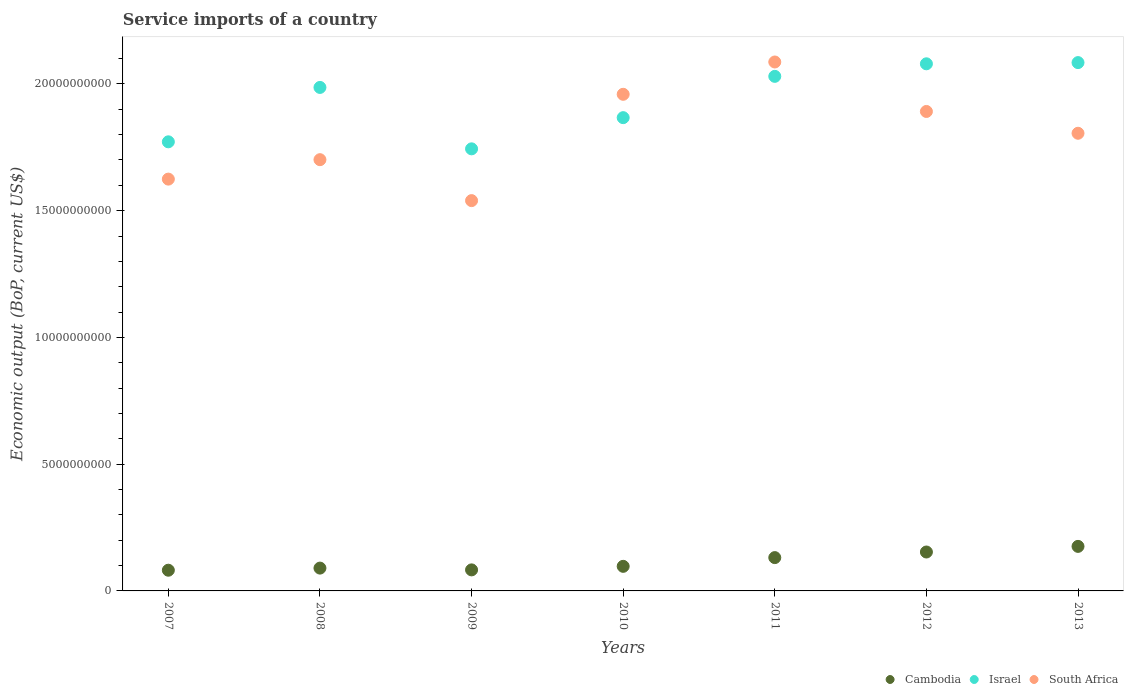How many different coloured dotlines are there?
Offer a terse response. 3. What is the service imports in South Africa in 2008?
Make the answer very short. 1.70e+1. Across all years, what is the maximum service imports in Israel?
Offer a very short reply. 2.08e+1. Across all years, what is the minimum service imports in Cambodia?
Provide a succinct answer. 8.17e+08. What is the total service imports in South Africa in the graph?
Make the answer very short. 1.26e+11. What is the difference between the service imports in South Africa in 2007 and that in 2009?
Offer a very short reply. 8.48e+08. What is the difference between the service imports in Cambodia in 2011 and the service imports in Israel in 2008?
Your response must be concise. -1.85e+1. What is the average service imports in South Africa per year?
Offer a very short reply. 1.80e+1. In the year 2009, what is the difference between the service imports in Cambodia and service imports in South Africa?
Ensure brevity in your answer.  -1.46e+1. What is the ratio of the service imports in South Africa in 2008 to that in 2011?
Provide a succinct answer. 0.82. What is the difference between the highest and the second highest service imports in Cambodia?
Provide a short and direct response. 2.22e+08. What is the difference between the highest and the lowest service imports in Cambodia?
Provide a succinct answer. 9.40e+08. In how many years, is the service imports in Israel greater than the average service imports in Israel taken over all years?
Give a very brief answer. 4. Is the sum of the service imports in Cambodia in 2008 and 2009 greater than the maximum service imports in Israel across all years?
Give a very brief answer. No. Is it the case that in every year, the sum of the service imports in Israel and service imports in Cambodia  is greater than the service imports in South Africa?
Your answer should be very brief. Yes. Does the service imports in South Africa monotonically increase over the years?
Provide a succinct answer. No. Is the service imports in Israel strictly greater than the service imports in South Africa over the years?
Your response must be concise. No. Is the service imports in South Africa strictly less than the service imports in Israel over the years?
Provide a succinct answer. No. How many dotlines are there?
Ensure brevity in your answer.  3. How many years are there in the graph?
Provide a short and direct response. 7. What is the difference between two consecutive major ticks on the Y-axis?
Give a very brief answer. 5.00e+09. Does the graph contain any zero values?
Make the answer very short. No. How many legend labels are there?
Offer a terse response. 3. What is the title of the graph?
Ensure brevity in your answer.  Service imports of a country. What is the label or title of the X-axis?
Provide a short and direct response. Years. What is the label or title of the Y-axis?
Ensure brevity in your answer.  Economic output (BoP, current US$). What is the Economic output (BoP, current US$) of Cambodia in 2007?
Keep it short and to the point. 8.17e+08. What is the Economic output (BoP, current US$) in Israel in 2007?
Provide a short and direct response. 1.77e+1. What is the Economic output (BoP, current US$) of South Africa in 2007?
Provide a short and direct response. 1.62e+1. What is the Economic output (BoP, current US$) in Cambodia in 2008?
Your response must be concise. 9.00e+08. What is the Economic output (BoP, current US$) of Israel in 2008?
Keep it short and to the point. 1.99e+1. What is the Economic output (BoP, current US$) of South Africa in 2008?
Ensure brevity in your answer.  1.70e+1. What is the Economic output (BoP, current US$) of Cambodia in 2009?
Give a very brief answer. 8.30e+08. What is the Economic output (BoP, current US$) of Israel in 2009?
Make the answer very short. 1.74e+1. What is the Economic output (BoP, current US$) in South Africa in 2009?
Offer a terse response. 1.54e+1. What is the Economic output (BoP, current US$) of Cambodia in 2010?
Provide a short and direct response. 9.70e+08. What is the Economic output (BoP, current US$) in Israel in 2010?
Your answer should be compact. 1.87e+1. What is the Economic output (BoP, current US$) in South Africa in 2010?
Your response must be concise. 1.96e+1. What is the Economic output (BoP, current US$) of Cambodia in 2011?
Offer a terse response. 1.31e+09. What is the Economic output (BoP, current US$) in Israel in 2011?
Your response must be concise. 2.03e+1. What is the Economic output (BoP, current US$) in South Africa in 2011?
Your response must be concise. 2.09e+1. What is the Economic output (BoP, current US$) in Cambodia in 2012?
Provide a short and direct response. 1.54e+09. What is the Economic output (BoP, current US$) in Israel in 2012?
Make the answer very short. 2.08e+1. What is the Economic output (BoP, current US$) of South Africa in 2012?
Make the answer very short. 1.89e+1. What is the Economic output (BoP, current US$) of Cambodia in 2013?
Offer a very short reply. 1.76e+09. What is the Economic output (BoP, current US$) of Israel in 2013?
Provide a succinct answer. 2.08e+1. What is the Economic output (BoP, current US$) of South Africa in 2013?
Give a very brief answer. 1.81e+1. Across all years, what is the maximum Economic output (BoP, current US$) in Cambodia?
Ensure brevity in your answer.  1.76e+09. Across all years, what is the maximum Economic output (BoP, current US$) in Israel?
Offer a very short reply. 2.08e+1. Across all years, what is the maximum Economic output (BoP, current US$) in South Africa?
Offer a terse response. 2.09e+1. Across all years, what is the minimum Economic output (BoP, current US$) in Cambodia?
Provide a succinct answer. 8.17e+08. Across all years, what is the minimum Economic output (BoP, current US$) of Israel?
Make the answer very short. 1.74e+1. Across all years, what is the minimum Economic output (BoP, current US$) of South Africa?
Provide a succinct answer. 1.54e+1. What is the total Economic output (BoP, current US$) in Cambodia in the graph?
Ensure brevity in your answer.  8.12e+09. What is the total Economic output (BoP, current US$) of Israel in the graph?
Your answer should be compact. 1.36e+11. What is the total Economic output (BoP, current US$) in South Africa in the graph?
Ensure brevity in your answer.  1.26e+11. What is the difference between the Economic output (BoP, current US$) in Cambodia in 2007 and that in 2008?
Your response must be concise. -8.33e+07. What is the difference between the Economic output (BoP, current US$) in Israel in 2007 and that in 2008?
Give a very brief answer. -2.15e+09. What is the difference between the Economic output (BoP, current US$) in South Africa in 2007 and that in 2008?
Make the answer very short. -7.67e+08. What is the difference between the Economic output (BoP, current US$) of Cambodia in 2007 and that in 2009?
Your answer should be very brief. -1.34e+07. What is the difference between the Economic output (BoP, current US$) in Israel in 2007 and that in 2009?
Make the answer very short. 2.77e+08. What is the difference between the Economic output (BoP, current US$) in South Africa in 2007 and that in 2009?
Ensure brevity in your answer.  8.48e+08. What is the difference between the Economic output (BoP, current US$) of Cambodia in 2007 and that in 2010?
Offer a very short reply. -1.53e+08. What is the difference between the Economic output (BoP, current US$) in Israel in 2007 and that in 2010?
Provide a short and direct response. -9.53e+08. What is the difference between the Economic output (BoP, current US$) in South Africa in 2007 and that in 2010?
Give a very brief answer. -3.35e+09. What is the difference between the Economic output (BoP, current US$) in Cambodia in 2007 and that in 2011?
Provide a short and direct response. -4.97e+08. What is the difference between the Economic output (BoP, current US$) in Israel in 2007 and that in 2011?
Offer a very short reply. -2.58e+09. What is the difference between the Economic output (BoP, current US$) of South Africa in 2007 and that in 2011?
Your answer should be compact. -4.62e+09. What is the difference between the Economic output (BoP, current US$) in Cambodia in 2007 and that in 2012?
Keep it short and to the point. -7.18e+08. What is the difference between the Economic output (BoP, current US$) in Israel in 2007 and that in 2012?
Offer a very short reply. -3.08e+09. What is the difference between the Economic output (BoP, current US$) in South Africa in 2007 and that in 2012?
Provide a succinct answer. -2.67e+09. What is the difference between the Economic output (BoP, current US$) in Cambodia in 2007 and that in 2013?
Make the answer very short. -9.40e+08. What is the difference between the Economic output (BoP, current US$) in Israel in 2007 and that in 2013?
Make the answer very short. -3.13e+09. What is the difference between the Economic output (BoP, current US$) of South Africa in 2007 and that in 2013?
Your answer should be compact. -1.81e+09. What is the difference between the Economic output (BoP, current US$) of Cambodia in 2008 and that in 2009?
Provide a succinct answer. 6.99e+07. What is the difference between the Economic output (BoP, current US$) of Israel in 2008 and that in 2009?
Provide a short and direct response. 2.42e+09. What is the difference between the Economic output (BoP, current US$) in South Africa in 2008 and that in 2009?
Your answer should be compact. 1.62e+09. What is the difference between the Economic output (BoP, current US$) of Cambodia in 2008 and that in 2010?
Your answer should be compact. -6.98e+07. What is the difference between the Economic output (BoP, current US$) of Israel in 2008 and that in 2010?
Offer a terse response. 1.19e+09. What is the difference between the Economic output (BoP, current US$) of South Africa in 2008 and that in 2010?
Keep it short and to the point. -2.58e+09. What is the difference between the Economic output (BoP, current US$) in Cambodia in 2008 and that in 2011?
Make the answer very short. -4.14e+08. What is the difference between the Economic output (BoP, current US$) of Israel in 2008 and that in 2011?
Your answer should be very brief. -4.37e+08. What is the difference between the Economic output (BoP, current US$) in South Africa in 2008 and that in 2011?
Keep it short and to the point. -3.85e+09. What is the difference between the Economic output (BoP, current US$) of Cambodia in 2008 and that in 2012?
Give a very brief answer. -6.35e+08. What is the difference between the Economic output (BoP, current US$) of Israel in 2008 and that in 2012?
Your response must be concise. -9.32e+08. What is the difference between the Economic output (BoP, current US$) in South Africa in 2008 and that in 2012?
Your answer should be very brief. -1.90e+09. What is the difference between the Economic output (BoP, current US$) of Cambodia in 2008 and that in 2013?
Offer a terse response. -8.57e+08. What is the difference between the Economic output (BoP, current US$) in Israel in 2008 and that in 2013?
Provide a short and direct response. -9.80e+08. What is the difference between the Economic output (BoP, current US$) of South Africa in 2008 and that in 2013?
Offer a terse response. -1.04e+09. What is the difference between the Economic output (BoP, current US$) of Cambodia in 2009 and that in 2010?
Your response must be concise. -1.40e+08. What is the difference between the Economic output (BoP, current US$) in Israel in 2009 and that in 2010?
Your answer should be compact. -1.23e+09. What is the difference between the Economic output (BoP, current US$) in South Africa in 2009 and that in 2010?
Your answer should be compact. -4.19e+09. What is the difference between the Economic output (BoP, current US$) of Cambodia in 2009 and that in 2011?
Ensure brevity in your answer.  -4.84e+08. What is the difference between the Economic output (BoP, current US$) of Israel in 2009 and that in 2011?
Make the answer very short. -2.86e+09. What is the difference between the Economic output (BoP, current US$) of South Africa in 2009 and that in 2011?
Make the answer very short. -5.47e+09. What is the difference between the Economic output (BoP, current US$) in Cambodia in 2009 and that in 2012?
Provide a succinct answer. -7.05e+08. What is the difference between the Economic output (BoP, current US$) of Israel in 2009 and that in 2012?
Offer a very short reply. -3.35e+09. What is the difference between the Economic output (BoP, current US$) in South Africa in 2009 and that in 2012?
Offer a terse response. -3.52e+09. What is the difference between the Economic output (BoP, current US$) of Cambodia in 2009 and that in 2013?
Keep it short and to the point. -9.27e+08. What is the difference between the Economic output (BoP, current US$) in Israel in 2009 and that in 2013?
Your answer should be compact. -3.40e+09. What is the difference between the Economic output (BoP, current US$) in South Africa in 2009 and that in 2013?
Ensure brevity in your answer.  -2.66e+09. What is the difference between the Economic output (BoP, current US$) in Cambodia in 2010 and that in 2011?
Provide a succinct answer. -3.44e+08. What is the difference between the Economic output (BoP, current US$) in Israel in 2010 and that in 2011?
Make the answer very short. -1.63e+09. What is the difference between the Economic output (BoP, current US$) of South Africa in 2010 and that in 2011?
Offer a very short reply. -1.27e+09. What is the difference between the Economic output (BoP, current US$) in Cambodia in 2010 and that in 2012?
Make the answer very short. -5.65e+08. What is the difference between the Economic output (BoP, current US$) in Israel in 2010 and that in 2012?
Keep it short and to the point. -2.12e+09. What is the difference between the Economic output (BoP, current US$) in South Africa in 2010 and that in 2012?
Provide a succinct answer. 6.77e+08. What is the difference between the Economic output (BoP, current US$) in Cambodia in 2010 and that in 2013?
Your response must be concise. -7.87e+08. What is the difference between the Economic output (BoP, current US$) in Israel in 2010 and that in 2013?
Provide a short and direct response. -2.17e+09. What is the difference between the Economic output (BoP, current US$) in South Africa in 2010 and that in 2013?
Ensure brevity in your answer.  1.54e+09. What is the difference between the Economic output (BoP, current US$) of Cambodia in 2011 and that in 2012?
Offer a very short reply. -2.21e+08. What is the difference between the Economic output (BoP, current US$) in Israel in 2011 and that in 2012?
Give a very brief answer. -4.95e+08. What is the difference between the Economic output (BoP, current US$) of South Africa in 2011 and that in 2012?
Give a very brief answer. 1.95e+09. What is the difference between the Economic output (BoP, current US$) in Cambodia in 2011 and that in 2013?
Give a very brief answer. -4.43e+08. What is the difference between the Economic output (BoP, current US$) of Israel in 2011 and that in 2013?
Provide a succinct answer. -5.43e+08. What is the difference between the Economic output (BoP, current US$) of South Africa in 2011 and that in 2013?
Your response must be concise. 2.81e+09. What is the difference between the Economic output (BoP, current US$) of Cambodia in 2012 and that in 2013?
Your response must be concise. -2.22e+08. What is the difference between the Economic output (BoP, current US$) of Israel in 2012 and that in 2013?
Offer a very short reply. -4.77e+07. What is the difference between the Economic output (BoP, current US$) in South Africa in 2012 and that in 2013?
Provide a short and direct response. 8.60e+08. What is the difference between the Economic output (BoP, current US$) of Cambodia in 2007 and the Economic output (BoP, current US$) of Israel in 2008?
Offer a terse response. -1.90e+1. What is the difference between the Economic output (BoP, current US$) in Cambodia in 2007 and the Economic output (BoP, current US$) in South Africa in 2008?
Keep it short and to the point. -1.62e+1. What is the difference between the Economic output (BoP, current US$) in Israel in 2007 and the Economic output (BoP, current US$) in South Africa in 2008?
Offer a terse response. 7.04e+08. What is the difference between the Economic output (BoP, current US$) in Cambodia in 2007 and the Economic output (BoP, current US$) in Israel in 2009?
Provide a short and direct response. -1.66e+1. What is the difference between the Economic output (BoP, current US$) in Cambodia in 2007 and the Economic output (BoP, current US$) in South Africa in 2009?
Offer a very short reply. -1.46e+1. What is the difference between the Economic output (BoP, current US$) of Israel in 2007 and the Economic output (BoP, current US$) of South Africa in 2009?
Offer a very short reply. 2.32e+09. What is the difference between the Economic output (BoP, current US$) in Cambodia in 2007 and the Economic output (BoP, current US$) in Israel in 2010?
Provide a short and direct response. -1.79e+1. What is the difference between the Economic output (BoP, current US$) in Cambodia in 2007 and the Economic output (BoP, current US$) in South Africa in 2010?
Your answer should be compact. -1.88e+1. What is the difference between the Economic output (BoP, current US$) of Israel in 2007 and the Economic output (BoP, current US$) of South Africa in 2010?
Ensure brevity in your answer.  -1.87e+09. What is the difference between the Economic output (BoP, current US$) in Cambodia in 2007 and the Economic output (BoP, current US$) in Israel in 2011?
Provide a succinct answer. -1.95e+1. What is the difference between the Economic output (BoP, current US$) of Cambodia in 2007 and the Economic output (BoP, current US$) of South Africa in 2011?
Offer a very short reply. -2.00e+1. What is the difference between the Economic output (BoP, current US$) in Israel in 2007 and the Economic output (BoP, current US$) in South Africa in 2011?
Offer a very short reply. -3.15e+09. What is the difference between the Economic output (BoP, current US$) in Cambodia in 2007 and the Economic output (BoP, current US$) in Israel in 2012?
Ensure brevity in your answer.  -2.00e+1. What is the difference between the Economic output (BoP, current US$) of Cambodia in 2007 and the Economic output (BoP, current US$) of South Africa in 2012?
Offer a very short reply. -1.81e+1. What is the difference between the Economic output (BoP, current US$) in Israel in 2007 and the Economic output (BoP, current US$) in South Africa in 2012?
Keep it short and to the point. -1.20e+09. What is the difference between the Economic output (BoP, current US$) in Cambodia in 2007 and the Economic output (BoP, current US$) in Israel in 2013?
Ensure brevity in your answer.  -2.00e+1. What is the difference between the Economic output (BoP, current US$) of Cambodia in 2007 and the Economic output (BoP, current US$) of South Africa in 2013?
Offer a very short reply. -1.72e+1. What is the difference between the Economic output (BoP, current US$) of Israel in 2007 and the Economic output (BoP, current US$) of South Africa in 2013?
Make the answer very short. -3.38e+08. What is the difference between the Economic output (BoP, current US$) of Cambodia in 2008 and the Economic output (BoP, current US$) of Israel in 2009?
Provide a succinct answer. -1.65e+1. What is the difference between the Economic output (BoP, current US$) in Cambodia in 2008 and the Economic output (BoP, current US$) in South Africa in 2009?
Provide a succinct answer. -1.45e+1. What is the difference between the Economic output (BoP, current US$) of Israel in 2008 and the Economic output (BoP, current US$) of South Africa in 2009?
Make the answer very short. 4.47e+09. What is the difference between the Economic output (BoP, current US$) of Cambodia in 2008 and the Economic output (BoP, current US$) of Israel in 2010?
Offer a terse response. -1.78e+1. What is the difference between the Economic output (BoP, current US$) in Cambodia in 2008 and the Economic output (BoP, current US$) in South Africa in 2010?
Provide a succinct answer. -1.87e+1. What is the difference between the Economic output (BoP, current US$) in Israel in 2008 and the Economic output (BoP, current US$) in South Africa in 2010?
Provide a succinct answer. 2.71e+08. What is the difference between the Economic output (BoP, current US$) in Cambodia in 2008 and the Economic output (BoP, current US$) in Israel in 2011?
Make the answer very short. -1.94e+1. What is the difference between the Economic output (BoP, current US$) of Cambodia in 2008 and the Economic output (BoP, current US$) of South Africa in 2011?
Provide a succinct answer. -2.00e+1. What is the difference between the Economic output (BoP, current US$) in Israel in 2008 and the Economic output (BoP, current US$) in South Africa in 2011?
Make the answer very short. -1.00e+09. What is the difference between the Economic output (BoP, current US$) in Cambodia in 2008 and the Economic output (BoP, current US$) in Israel in 2012?
Your answer should be compact. -1.99e+1. What is the difference between the Economic output (BoP, current US$) in Cambodia in 2008 and the Economic output (BoP, current US$) in South Africa in 2012?
Offer a terse response. -1.80e+1. What is the difference between the Economic output (BoP, current US$) in Israel in 2008 and the Economic output (BoP, current US$) in South Africa in 2012?
Your answer should be very brief. 9.48e+08. What is the difference between the Economic output (BoP, current US$) in Cambodia in 2008 and the Economic output (BoP, current US$) in Israel in 2013?
Give a very brief answer. -1.99e+1. What is the difference between the Economic output (BoP, current US$) in Cambodia in 2008 and the Economic output (BoP, current US$) in South Africa in 2013?
Offer a very short reply. -1.72e+1. What is the difference between the Economic output (BoP, current US$) in Israel in 2008 and the Economic output (BoP, current US$) in South Africa in 2013?
Your answer should be compact. 1.81e+09. What is the difference between the Economic output (BoP, current US$) of Cambodia in 2009 and the Economic output (BoP, current US$) of Israel in 2010?
Provide a succinct answer. -1.78e+1. What is the difference between the Economic output (BoP, current US$) in Cambodia in 2009 and the Economic output (BoP, current US$) in South Africa in 2010?
Your answer should be very brief. -1.88e+1. What is the difference between the Economic output (BoP, current US$) in Israel in 2009 and the Economic output (BoP, current US$) in South Africa in 2010?
Ensure brevity in your answer.  -2.15e+09. What is the difference between the Economic output (BoP, current US$) in Cambodia in 2009 and the Economic output (BoP, current US$) in Israel in 2011?
Offer a very short reply. -1.95e+1. What is the difference between the Economic output (BoP, current US$) of Cambodia in 2009 and the Economic output (BoP, current US$) of South Africa in 2011?
Give a very brief answer. -2.00e+1. What is the difference between the Economic output (BoP, current US$) in Israel in 2009 and the Economic output (BoP, current US$) in South Africa in 2011?
Keep it short and to the point. -3.43e+09. What is the difference between the Economic output (BoP, current US$) of Cambodia in 2009 and the Economic output (BoP, current US$) of Israel in 2012?
Ensure brevity in your answer.  -2.00e+1. What is the difference between the Economic output (BoP, current US$) of Cambodia in 2009 and the Economic output (BoP, current US$) of South Africa in 2012?
Provide a succinct answer. -1.81e+1. What is the difference between the Economic output (BoP, current US$) of Israel in 2009 and the Economic output (BoP, current US$) of South Africa in 2012?
Offer a very short reply. -1.47e+09. What is the difference between the Economic output (BoP, current US$) of Cambodia in 2009 and the Economic output (BoP, current US$) of Israel in 2013?
Give a very brief answer. -2.00e+1. What is the difference between the Economic output (BoP, current US$) of Cambodia in 2009 and the Economic output (BoP, current US$) of South Africa in 2013?
Ensure brevity in your answer.  -1.72e+1. What is the difference between the Economic output (BoP, current US$) in Israel in 2009 and the Economic output (BoP, current US$) in South Africa in 2013?
Your response must be concise. -6.14e+08. What is the difference between the Economic output (BoP, current US$) in Cambodia in 2010 and the Economic output (BoP, current US$) in Israel in 2011?
Offer a terse response. -1.93e+1. What is the difference between the Economic output (BoP, current US$) in Cambodia in 2010 and the Economic output (BoP, current US$) in South Africa in 2011?
Your answer should be compact. -1.99e+1. What is the difference between the Economic output (BoP, current US$) of Israel in 2010 and the Economic output (BoP, current US$) of South Africa in 2011?
Give a very brief answer. -2.20e+09. What is the difference between the Economic output (BoP, current US$) of Cambodia in 2010 and the Economic output (BoP, current US$) of Israel in 2012?
Your response must be concise. -1.98e+1. What is the difference between the Economic output (BoP, current US$) of Cambodia in 2010 and the Economic output (BoP, current US$) of South Africa in 2012?
Keep it short and to the point. -1.79e+1. What is the difference between the Economic output (BoP, current US$) of Israel in 2010 and the Economic output (BoP, current US$) of South Africa in 2012?
Offer a very short reply. -2.44e+08. What is the difference between the Economic output (BoP, current US$) in Cambodia in 2010 and the Economic output (BoP, current US$) in Israel in 2013?
Your answer should be compact. -1.99e+1. What is the difference between the Economic output (BoP, current US$) in Cambodia in 2010 and the Economic output (BoP, current US$) in South Africa in 2013?
Provide a succinct answer. -1.71e+1. What is the difference between the Economic output (BoP, current US$) of Israel in 2010 and the Economic output (BoP, current US$) of South Africa in 2013?
Your answer should be very brief. 6.16e+08. What is the difference between the Economic output (BoP, current US$) of Cambodia in 2011 and the Economic output (BoP, current US$) of Israel in 2012?
Provide a succinct answer. -1.95e+1. What is the difference between the Economic output (BoP, current US$) in Cambodia in 2011 and the Economic output (BoP, current US$) in South Africa in 2012?
Keep it short and to the point. -1.76e+1. What is the difference between the Economic output (BoP, current US$) of Israel in 2011 and the Economic output (BoP, current US$) of South Africa in 2012?
Your answer should be compact. 1.38e+09. What is the difference between the Economic output (BoP, current US$) of Cambodia in 2011 and the Economic output (BoP, current US$) of Israel in 2013?
Offer a very short reply. -1.95e+1. What is the difference between the Economic output (BoP, current US$) in Cambodia in 2011 and the Economic output (BoP, current US$) in South Africa in 2013?
Provide a short and direct response. -1.67e+1. What is the difference between the Economic output (BoP, current US$) of Israel in 2011 and the Economic output (BoP, current US$) of South Africa in 2013?
Give a very brief answer. 2.25e+09. What is the difference between the Economic output (BoP, current US$) in Cambodia in 2012 and the Economic output (BoP, current US$) in Israel in 2013?
Your response must be concise. -1.93e+1. What is the difference between the Economic output (BoP, current US$) of Cambodia in 2012 and the Economic output (BoP, current US$) of South Africa in 2013?
Make the answer very short. -1.65e+1. What is the difference between the Economic output (BoP, current US$) in Israel in 2012 and the Economic output (BoP, current US$) in South Africa in 2013?
Keep it short and to the point. 2.74e+09. What is the average Economic output (BoP, current US$) of Cambodia per year?
Offer a very short reply. 1.16e+09. What is the average Economic output (BoP, current US$) in Israel per year?
Ensure brevity in your answer.  1.94e+1. What is the average Economic output (BoP, current US$) in South Africa per year?
Your response must be concise. 1.80e+1. In the year 2007, what is the difference between the Economic output (BoP, current US$) in Cambodia and Economic output (BoP, current US$) in Israel?
Ensure brevity in your answer.  -1.69e+1. In the year 2007, what is the difference between the Economic output (BoP, current US$) in Cambodia and Economic output (BoP, current US$) in South Africa?
Ensure brevity in your answer.  -1.54e+1. In the year 2007, what is the difference between the Economic output (BoP, current US$) in Israel and Economic output (BoP, current US$) in South Africa?
Your answer should be compact. 1.47e+09. In the year 2008, what is the difference between the Economic output (BoP, current US$) in Cambodia and Economic output (BoP, current US$) in Israel?
Offer a terse response. -1.90e+1. In the year 2008, what is the difference between the Economic output (BoP, current US$) in Cambodia and Economic output (BoP, current US$) in South Africa?
Give a very brief answer. -1.61e+1. In the year 2008, what is the difference between the Economic output (BoP, current US$) in Israel and Economic output (BoP, current US$) in South Africa?
Keep it short and to the point. 2.85e+09. In the year 2009, what is the difference between the Economic output (BoP, current US$) of Cambodia and Economic output (BoP, current US$) of Israel?
Your answer should be compact. -1.66e+1. In the year 2009, what is the difference between the Economic output (BoP, current US$) in Cambodia and Economic output (BoP, current US$) in South Africa?
Give a very brief answer. -1.46e+1. In the year 2009, what is the difference between the Economic output (BoP, current US$) in Israel and Economic output (BoP, current US$) in South Africa?
Provide a short and direct response. 2.04e+09. In the year 2010, what is the difference between the Economic output (BoP, current US$) of Cambodia and Economic output (BoP, current US$) of Israel?
Offer a very short reply. -1.77e+1. In the year 2010, what is the difference between the Economic output (BoP, current US$) of Cambodia and Economic output (BoP, current US$) of South Africa?
Your answer should be very brief. -1.86e+1. In the year 2010, what is the difference between the Economic output (BoP, current US$) in Israel and Economic output (BoP, current US$) in South Africa?
Make the answer very short. -9.21e+08. In the year 2011, what is the difference between the Economic output (BoP, current US$) in Cambodia and Economic output (BoP, current US$) in Israel?
Give a very brief answer. -1.90e+1. In the year 2011, what is the difference between the Economic output (BoP, current US$) in Cambodia and Economic output (BoP, current US$) in South Africa?
Provide a succinct answer. -1.96e+1. In the year 2011, what is the difference between the Economic output (BoP, current US$) in Israel and Economic output (BoP, current US$) in South Africa?
Make the answer very short. -5.67e+08. In the year 2012, what is the difference between the Economic output (BoP, current US$) in Cambodia and Economic output (BoP, current US$) in Israel?
Offer a terse response. -1.93e+1. In the year 2012, what is the difference between the Economic output (BoP, current US$) in Cambodia and Economic output (BoP, current US$) in South Africa?
Provide a succinct answer. -1.74e+1. In the year 2012, what is the difference between the Economic output (BoP, current US$) in Israel and Economic output (BoP, current US$) in South Africa?
Offer a very short reply. 1.88e+09. In the year 2013, what is the difference between the Economic output (BoP, current US$) in Cambodia and Economic output (BoP, current US$) in Israel?
Make the answer very short. -1.91e+1. In the year 2013, what is the difference between the Economic output (BoP, current US$) of Cambodia and Economic output (BoP, current US$) of South Africa?
Your answer should be very brief. -1.63e+1. In the year 2013, what is the difference between the Economic output (BoP, current US$) of Israel and Economic output (BoP, current US$) of South Africa?
Your answer should be very brief. 2.79e+09. What is the ratio of the Economic output (BoP, current US$) of Cambodia in 2007 to that in 2008?
Give a very brief answer. 0.91. What is the ratio of the Economic output (BoP, current US$) in Israel in 2007 to that in 2008?
Provide a succinct answer. 0.89. What is the ratio of the Economic output (BoP, current US$) of South Africa in 2007 to that in 2008?
Make the answer very short. 0.95. What is the ratio of the Economic output (BoP, current US$) of Cambodia in 2007 to that in 2009?
Make the answer very short. 0.98. What is the ratio of the Economic output (BoP, current US$) in Israel in 2007 to that in 2009?
Offer a terse response. 1.02. What is the ratio of the Economic output (BoP, current US$) of South Africa in 2007 to that in 2009?
Offer a very short reply. 1.06. What is the ratio of the Economic output (BoP, current US$) of Cambodia in 2007 to that in 2010?
Your answer should be compact. 0.84. What is the ratio of the Economic output (BoP, current US$) in Israel in 2007 to that in 2010?
Make the answer very short. 0.95. What is the ratio of the Economic output (BoP, current US$) in South Africa in 2007 to that in 2010?
Give a very brief answer. 0.83. What is the ratio of the Economic output (BoP, current US$) in Cambodia in 2007 to that in 2011?
Provide a short and direct response. 0.62. What is the ratio of the Economic output (BoP, current US$) in Israel in 2007 to that in 2011?
Your answer should be very brief. 0.87. What is the ratio of the Economic output (BoP, current US$) in South Africa in 2007 to that in 2011?
Give a very brief answer. 0.78. What is the ratio of the Economic output (BoP, current US$) of Cambodia in 2007 to that in 2012?
Offer a terse response. 0.53. What is the ratio of the Economic output (BoP, current US$) of Israel in 2007 to that in 2012?
Make the answer very short. 0.85. What is the ratio of the Economic output (BoP, current US$) of South Africa in 2007 to that in 2012?
Offer a terse response. 0.86. What is the ratio of the Economic output (BoP, current US$) in Cambodia in 2007 to that in 2013?
Your answer should be very brief. 0.46. What is the ratio of the Economic output (BoP, current US$) of South Africa in 2007 to that in 2013?
Make the answer very short. 0.9. What is the ratio of the Economic output (BoP, current US$) of Cambodia in 2008 to that in 2009?
Your answer should be very brief. 1.08. What is the ratio of the Economic output (BoP, current US$) in Israel in 2008 to that in 2009?
Give a very brief answer. 1.14. What is the ratio of the Economic output (BoP, current US$) in South Africa in 2008 to that in 2009?
Your response must be concise. 1.1. What is the ratio of the Economic output (BoP, current US$) in Cambodia in 2008 to that in 2010?
Keep it short and to the point. 0.93. What is the ratio of the Economic output (BoP, current US$) in Israel in 2008 to that in 2010?
Provide a short and direct response. 1.06. What is the ratio of the Economic output (BoP, current US$) of South Africa in 2008 to that in 2010?
Offer a terse response. 0.87. What is the ratio of the Economic output (BoP, current US$) in Cambodia in 2008 to that in 2011?
Offer a very short reply. 0.68. What is the ratio of the Economic output (BoP, current US$) in Israel in 2008 to that in 2011?
Your answer should be compact. 0.98. What is the ratio of the Economic output (BoP, current US$) in South Africa in 2008 to that in 2011?
Ensure brevity in your answer.  0.82. What is the ratio of the Economic output (BoP, current US$) in Cambodia in 2008 to that in 2012?
Keep it short and to the point. 0.59. What is the ratio of the Economic output (BoP, current US$) in Israel in 2008 to that in 2012?
Give a very brief answer. 0.96. What is the ratio of the Economic output (BoP, current US$) in South Africa in 2008 to that in 2012?
Provide a short and direct response. 0.9. What is the ratio of the Economic output (BoP, current US$) in Cambodia in 2008 to that in 2013?
Make the answer very short. 0.51. What is the ratio of the Economic output (BoP, current US$) of Israel in 2008 to that in 2013?
Ensure brevity in your answer.  0.95. What is the ratio of the Economic output (BoP, current US$) of South Africa in 2008 to that in 2013?
Give a very brief answer. 0.94. What is the ratio of the Economic output (BoP, current US$) of Cambodia in 2009 to that in 2010?
Provide a short and direct response. 0.86. What is the ratio of the Economic output (BoP, current US$) of Israel in 2009 to that in 2010?
Provide a short and direct response. 0.93. What is the ratio of the Economic output (BoP, current US$) of South Africa in 2009 to that in 2010?
Provide a succinct answer. 0.79. What is the ratio of the Economic output (BoP, current US$) of Cambodia in 2009 to that in 2011?
Offer a terse response. 0.63. What is the ratio of the Economic output (BoP, current US$) of Israel in 2009 to that in 2011?
Give a very brief answer. 0.86. What is the ratio of the Economic output (BoP, current US$) in South Africa in 2009 to that in 2011?
Keep it short and to the point. 0.74. What is the ratio of the Economic output (BoP, current US$) of Cambodia in 2009 to that in 2012?
Ensure brevity in your answer.  0.54. What is the ratio of the Economic output (BoP, current US$) of Israel in 2009 to that in 2012?
Ensure brevity in your answer.  0.84. What is the ratio of the Economic output (BoP, current US$) in South Africa in 2009 to that in 2012?
Your answer should be very brief. 0.81. What is the ratio of the Economic output (BoP, current US$) of Cambodia in 2009 to that in 2013?
Provide a succinct answer. 0.47. What is the ratio of the Economic output (BoP, current US$) of Israel in 2009 to that in 2013?
Provide a succinct answer. 0.84. What is the ratio of the Economic output (BoP, current US$) of South Africa in 2009 to that in 2013?
Give a very brief answer. 0.85. What is the ratio of the Economic output (BoP, current US$) of Cambodia in 2010 to that in 2011?
Provide a short and direct response. 0.74. What is the ratio of the Economic output (BoP, current US$) of Israel in 2010 to that in 2011?
Provide a short and direct response. 0.92. What is the ratio of the Economic output (BoP, current US$) of South Africa in 2010 to that in 2011?
Make the answer very short. 0.94. What is the ratio of the Economic output (BoP, current US$) of Cambodia in 2010 to that in 2012?
Offer a terse response. 0.63. What is the ratio of the Economic output (BoP, current US$) of Israel in 2010 to that in 2012?
Give a very brief answer. 0.9. What is the ratio of the Economic output (BoP, current US$) of South Africa in 2010 to that in 2012?
Provide a short and direct response. 1.04. What is the ratio of the Economic output (BoP, current US$) of Cambodia in 2010 to that in 2013?
Offer a terse response. 0.55. What is the ratio of the Economic output (BoP, current US$) of Israel in 2010 to that in 2013?
Your answer should be compact. 0.9. What is the ratio of the Economic output (BoP, current US$) in South Africa in 2010 to that in 2013?
Offer a very short reply. 1.09. What is the ratio of the Economic output (BoP, current US$) in Cambodia in 2011 to that in 2012?
Provide a succinct answer. 0.86. What is the ratio of the Economic output (BoP, current US$) of Israel in 2011 to that in 2012?
Your answer should be very brief. 0.98. What is the ratio of the Economic output (BoP, current US$) of South Africa in 2011 to that in 2012?
Ensure brevity in your answer.  1.1. What is the ratio of the Economic output (BoP, current US$) of Cambodia in 2011 to that in 2013?
Keep it short and to the point. 0.75. What is the ratio of the Economic output (BoP, current US$) in Israel in 2011 to that in 2013?
Your answer should be very brief. 0.97. What is the ratio of the Economic output (BoP, current US$) of South Africa in 2011 to that in 2013?
Your response must be concise. 1.16. What is the ratio of the Economic output (BoP, current US$) of Cambodia in 2012 to that in 2013?
Give a very brief answer. 0.87. What is the ratio of the Economic output (BoP, current US$) in South Africa in 2012 to that in 2013?
Provide a short and direct response. 1.05. What is the difference between the highest and the second highest Economic output (BoP, current US$) in Cambodia?
Give a very brief answer. 2.22e+08. What is the difference between the highest and the second highest Economic output (BoP, current US$) of Israel?
Provide a short and direct response. 4.77e+07. What is the difference between the highest and the second highest Economic output (BoP, current US$) in South Africa?
Your answer should be very brief. 1.27e+09. What is the difference between the highest and the lowest Economic output (BoP, current US$) in Cambodia?
Give a very brief answer. 9.40e+08. What is the difference between the highest and the lowest Economic output (BoP, current US$) of Israel?
Make the answer very short. 3.40e+09. What is the difference between the highest and the lowest Economic output (BoP, current US$) in South Africa?
Provide a succinct answer. 5.47e+09. 